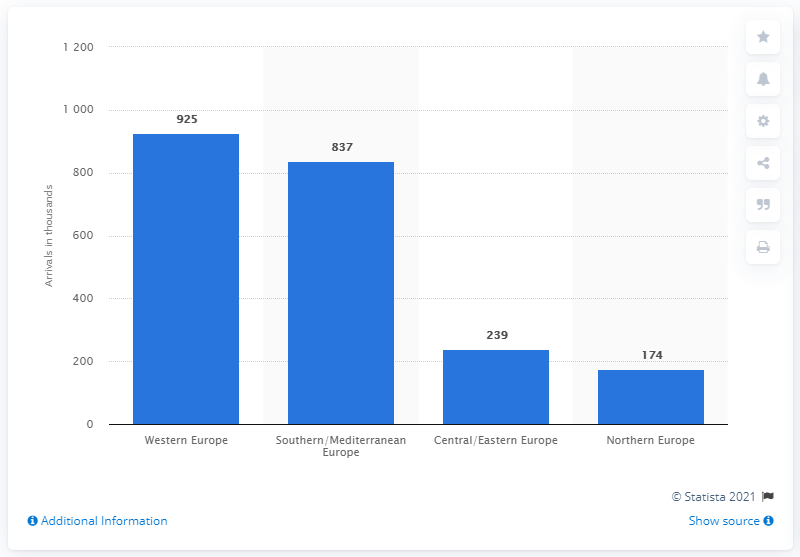Identify some key points in this picture. According to data from 2019, the region that was most frequently visited by Mexican tourists was Western Europe. 